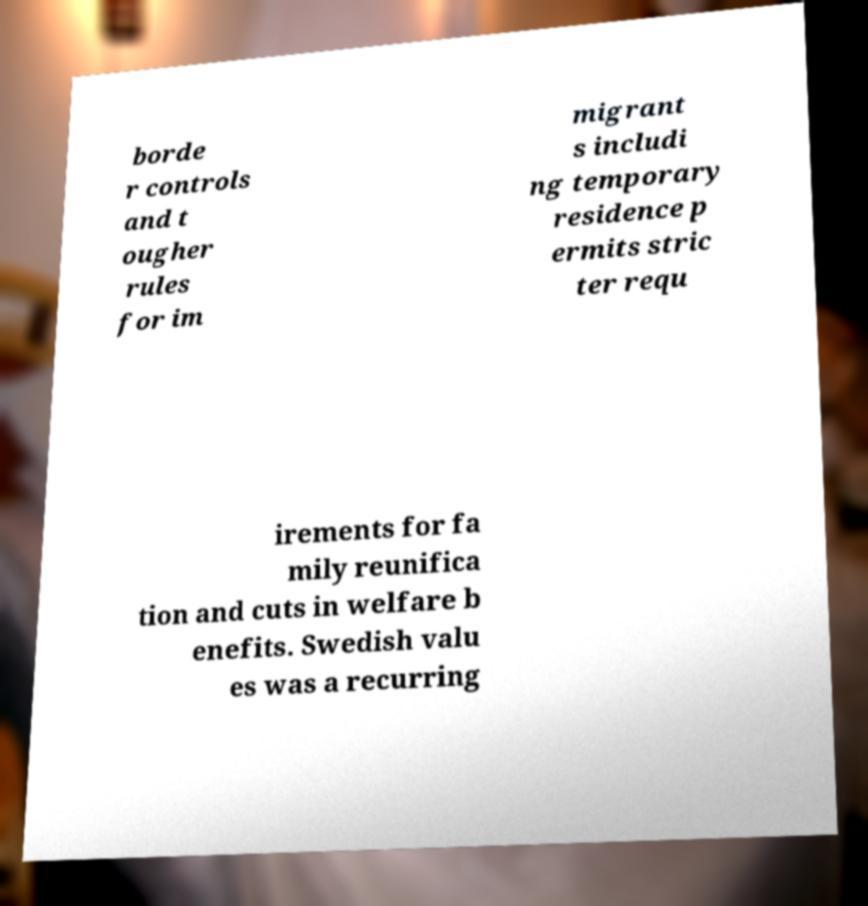What messages or text are displayed in this image? I need them in a readable, typed format. borde r controls and t ougher rules for im migrant s includi ng temporary residence p ermits stric ter requ irements for fa mily reunifica tion and cuts in welfare b enefits. Swedish valu es was a recurring 